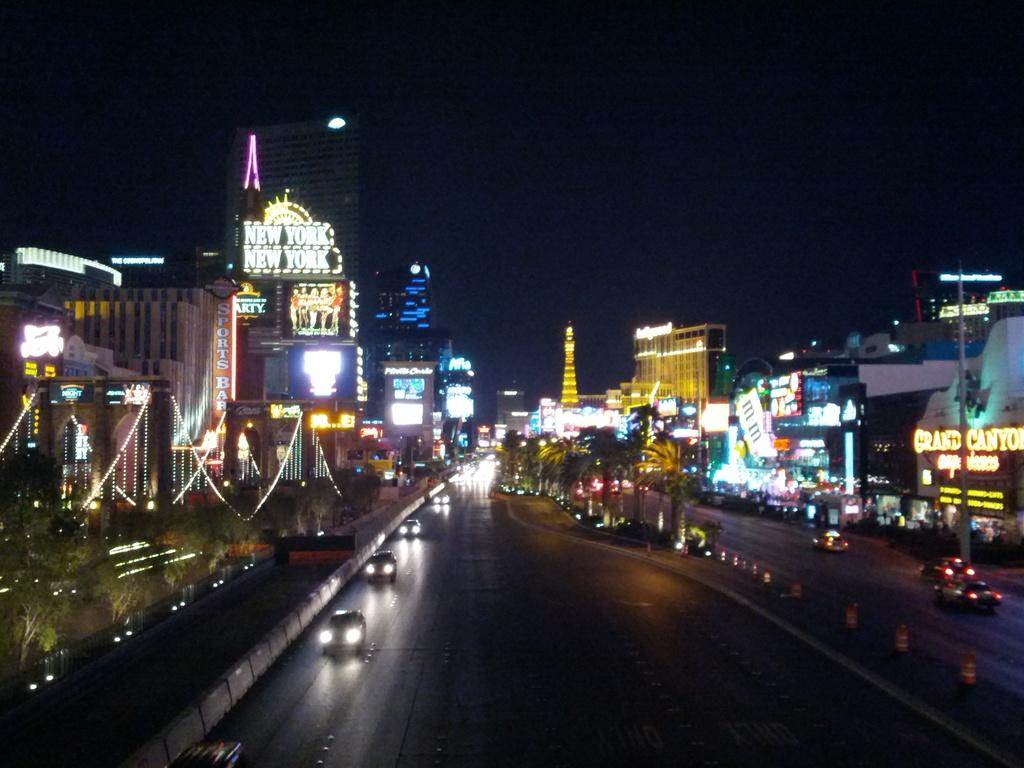What is located in the center of the image? There are vehicles on the road in the center of the image. What type of natural elements can be seen in the image? There are trees visible in the image. What can be seen in the background of the image? There are buildings, lights, and the sky visible in the background of the image. What type of jeans is the band wearing in the image? There is no band present in the image, so it is not possible to determine what type of jeans they might be wearing. 